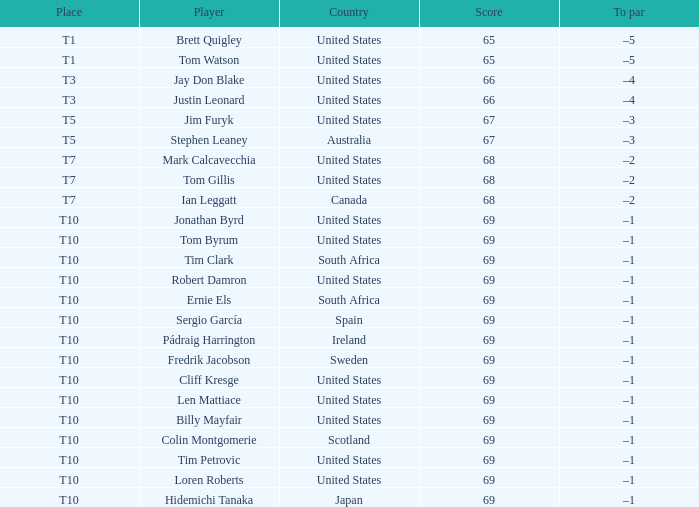What is Tom Gillis' score? 68.0. 